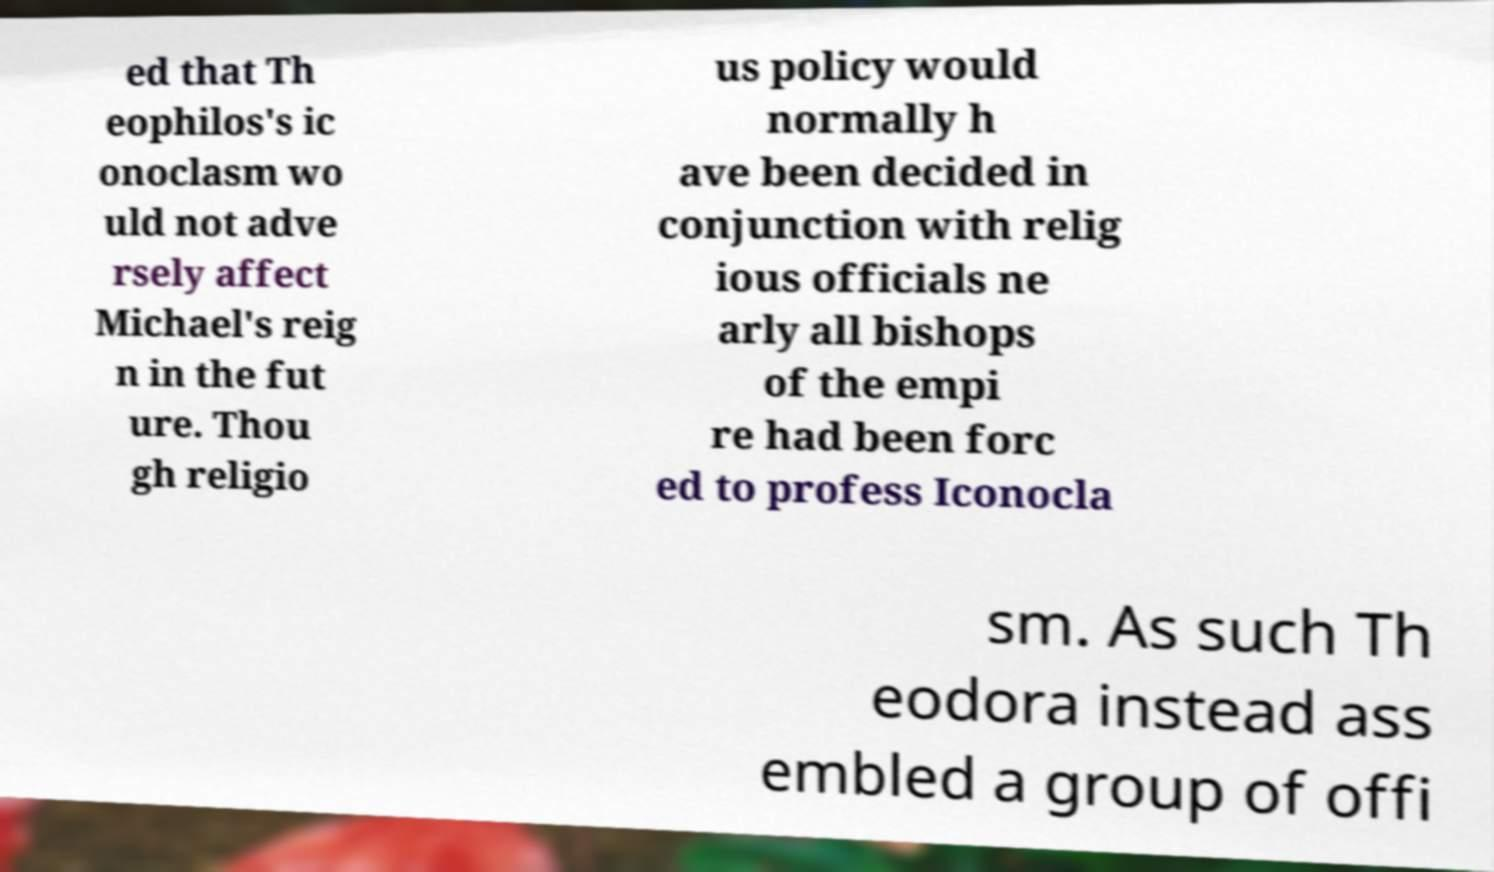What messages or text are displayed in this image? I need them in a readable, typed format. ed that Th eophilos's ic onoclasm wo uld not adve rsely affect Michael's reig n in the fut ure. Thou gh religio us policy would normally h ave been decided in conjunction with relig ious officials ne arly all bishops of the empi re had been forc ed to profess Iconocla sm. As such Th eodora instead ass embled a group of offi 